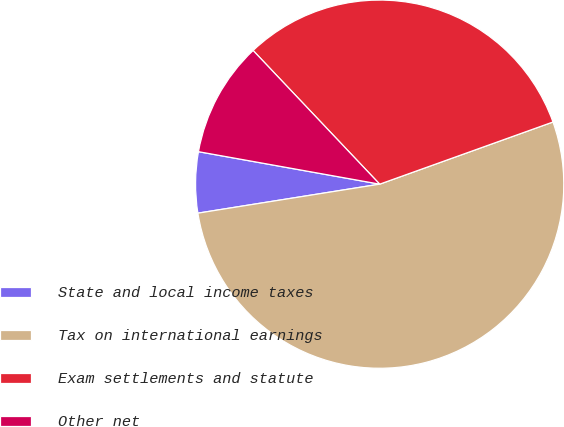<chart> <loc_0><loc_0><loc_500><loc_500><pie_chart><fcel>State and local income taxes<fcel>Tax on international earnings<fcel>Exam settlements and statute<fcel>Other net<nl><fcel>5.34%<fcel>52.96%<fcel>31.58%<fcel>10.11%<nl></chart> 